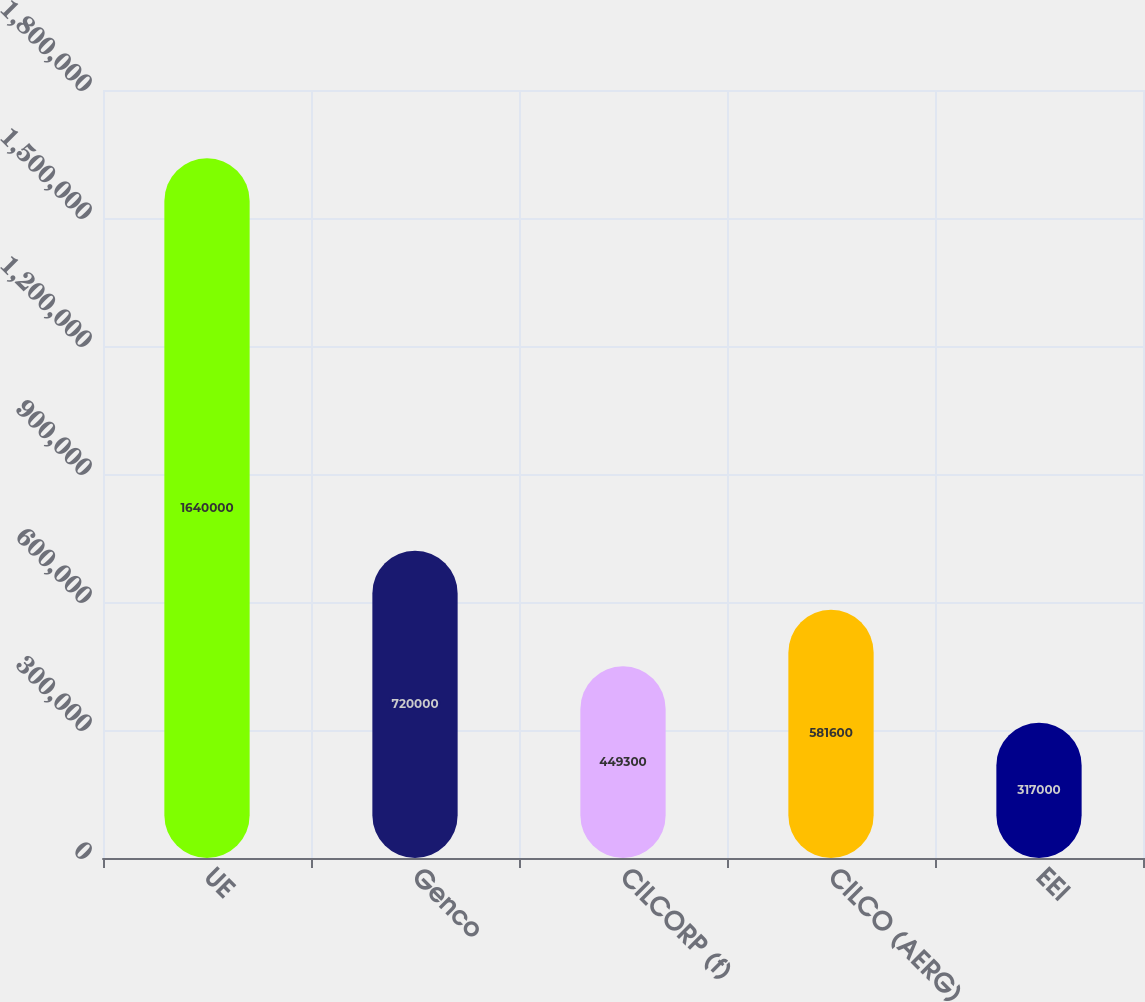Convert chart. <chart><loc_0><loc_0><loc_500><loc_500><bar_chart><fcel>UE<fcel>Genco<fcel>CILCORP (f)<fcel>CILCO (AERG)<fcel>EEI<nl><fcel>1.64e+06<fcel>720000<fcel>449300<fcel>581600<fcel>317000<nl></chart> 